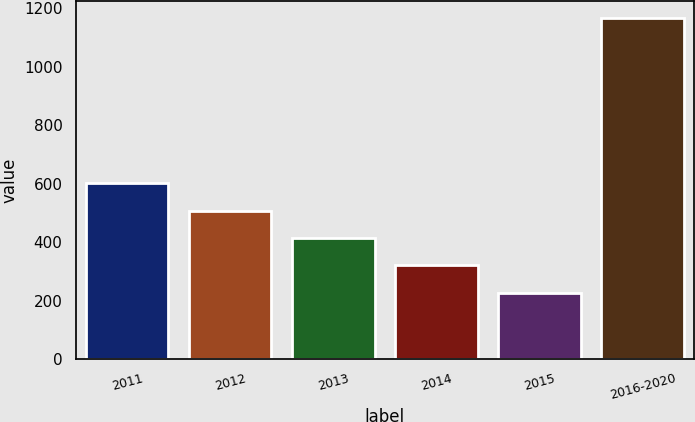Convert chart to OTSL. <chart><loc_0><loc_0><loc_500><loc_500><bar_chart><fcel>2011<fcel>2012<fcel>2013<fcel>2014<fcel>2015<fcel>2016-2020<nl><fcel>601.6<fcel>507.7<fcel>413.8<fcel>319.9<fcel>226<fcel>1165<nl></chart> 